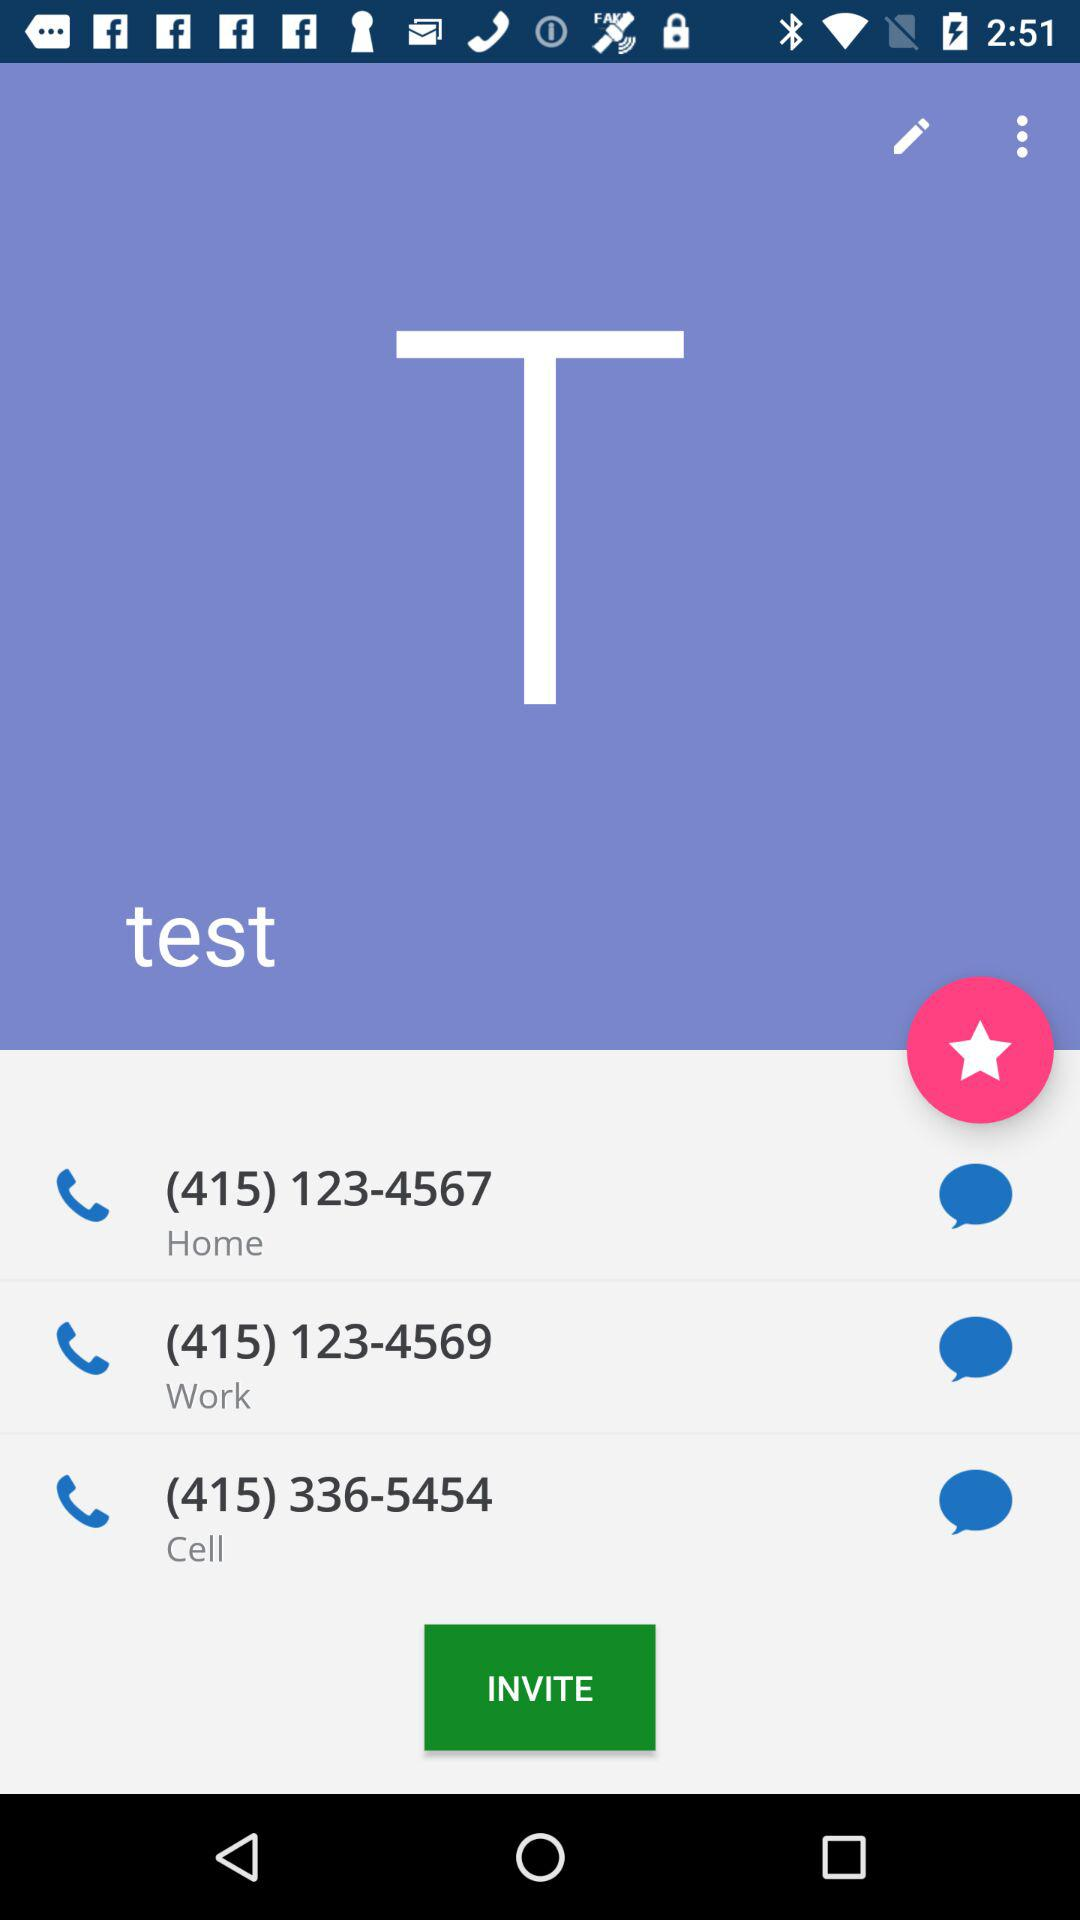What is the phone number shown on the screen? The phone numbers shown on the screen are (415) 123-4567, (415) 123-4569 and (415) 336-5454. 